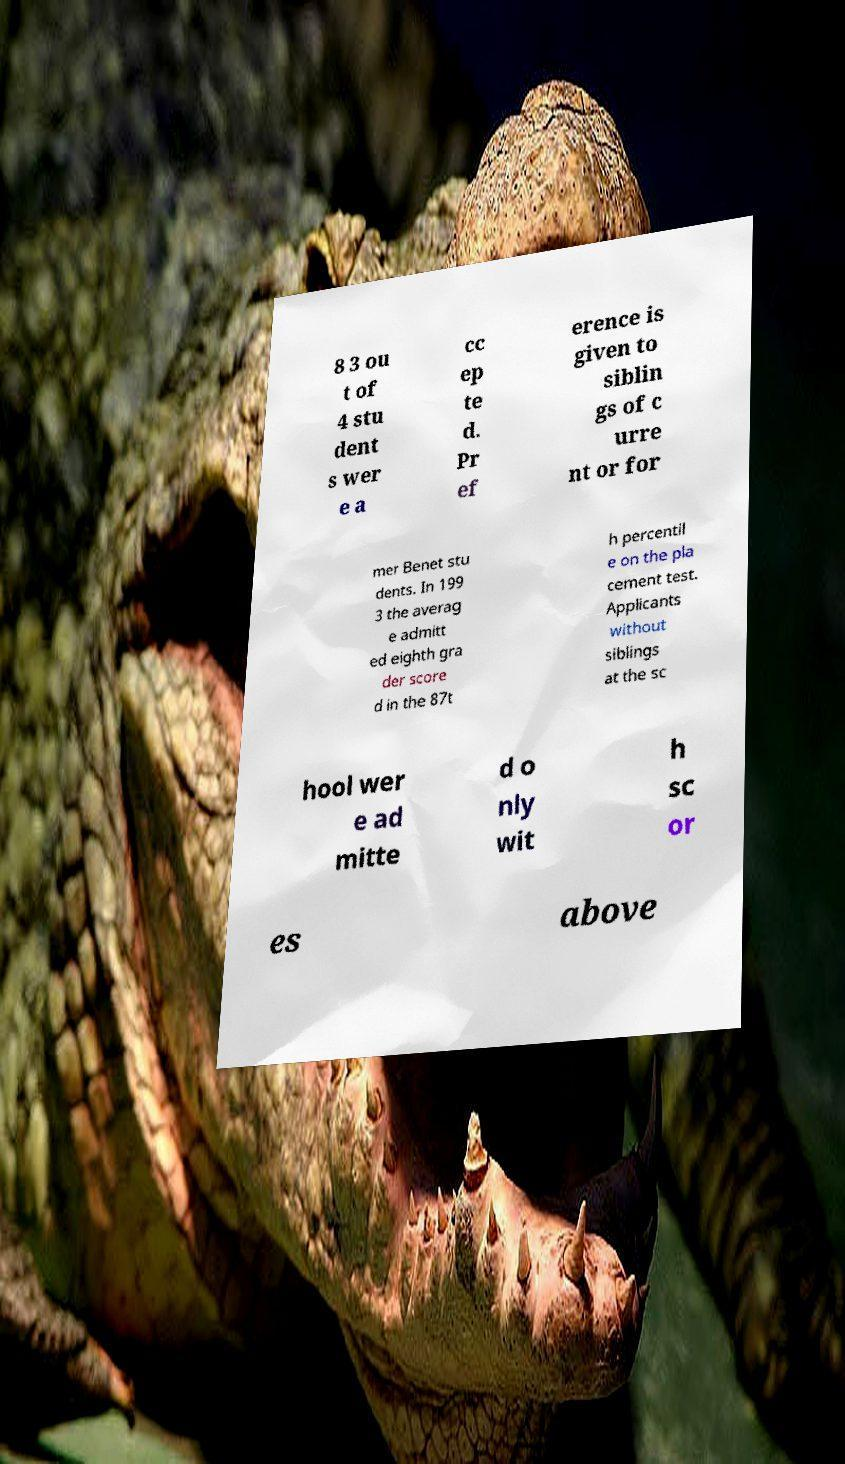For documentation purposes, I need the text within this image transcribed. Could you provide that? 8 3 ou t of 4 stu dent s wer e a cc ep te d. Pr ef erence is given to siblin gs of c urre nt or for mer Benet stu dents. In 199 3 the averag e admitt ed eighth gra der score d in the 87t h percentil e on the pla cement test. Applicants without siblings at the sc hool wer e ad mitte d o nly wit h sc or es above 